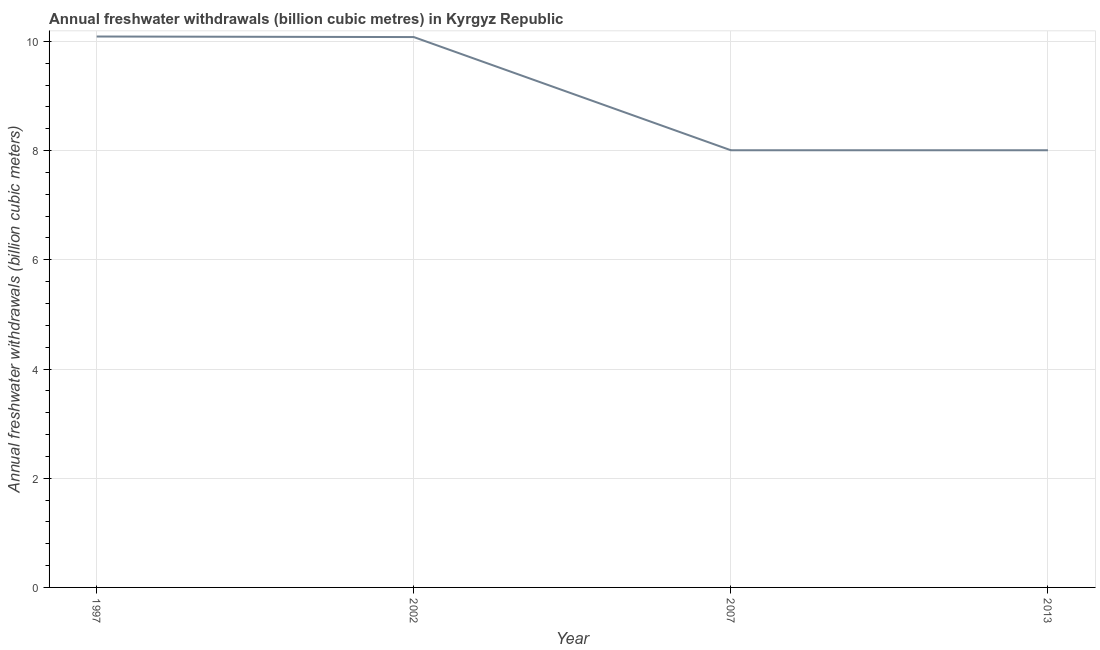What is the annual freshwater withdrawals in 2007?
Provide a short and direct response. 8.01. Across all years, what is the maximum annual freshwater withdrawals?
Ensure brevity in your answer.  10.09. Across all years, what is the minimum annual freshwater withdrawals?
Keep it short and to the point. 8.01. What is the sum of the annual freshwater withdrawals?
Ensure brevity in your answer.  36.18. What is the difference between the annual freshwater withdrawals in 2002 and 2013?
Ensure brevity in your answer.  2.07. What is the average annual freshwater withdrawals per year?
Your answer should be very brief. 9.05. What is the median annual freshwater withdrawals?
Your answer should be very brief. 9.04. In how many years, is the annual freshwater withdrawals greater than 5.2 billion cubic meters?
Give a very brief answer. 4. What is the ratio of the annual freshwater withdrawals in 1997 to that in 2013?
Your answer should be very brief. 1.26. Is the annual freshwater withdrawals in 2007 less than that in 2013?
Your answer should be very brief. No. Is the difference between the annual freshwater withdrawals in 1997 and 2013 greater than the difference between any two years?
Give a very brief answer. Yes. What is the difference between the highest and the second highest annual freshwater withdrawals?
Provide a short and direct response. 0.01. What is the difference between the highest and the lowest annual freshwater withdrawals?
Your answer should be compact. 2.08. Does the annual freshwater withdrawals monotonically increase over the years?
Your answer should be compact. No. Are the values on the major ticks of Y-axis written in scientific E-notation?
Keep it short and to the point. No. What is the title of the graph?
Provide a short and direct response. Annual freshwater withdrawals (billion cubic metres) in Kyrgyz Republic. What is the label or title of the X-axis?
Give a very brief answer. Year. What is the label or title of the Y-axis?
Keep it short and to the point. Annual freshwater withdrawals (billion cubic meters). What is the Annual freshwater withdrawals (billion cubic meters) in 1997?
Ensure brevity in your answer.  10.09. What is the Annual freshwater withdrawals (billion cubic meters) in 2002?
Your answer should be very brief. 10.08. What is the Annual freshwater withdrawals (billion cubic meters) of 2007?
Offer a very short reply. 8.01. What is the Annual freshwater withdrawals (billion cubic meters) in 2013?
Make the answer very short. 8.01. What is the difference between the Annual freshwater withdrawals (billion cubic meters) in 1997 and 2007?
Give a very brief answer. 2.08. What is the difference between the Annual freshwater withdrawals (billion cubic meters) in 1997 and 2013?
Provide a short and direct response. 2.08. What is the difference between the Annual freshwater withdrawals (billion cubic meters) in 2002 and 2007?
Your answer should be very brief. 2.07. What is the difference between the Annual freshwater withdrawals (billion cubic meters) in 2002 and 2013?
Provide a succinct answer. 2.07. What is the ratio of the Annual freshwater withdrawals (billion cubic meters) in 1997 to that in 2002?
Keep it short and to the point. 1. What is the ratio of the Annual freshwater withdrawals (billion cubic meters) in 1997 to that in 2007?
Offer a very short reply. 1.26. What is the ratio of the Annual freshwater withdrawals (billion cubic meters) in 1997 to that in 2013?
Make the answer very short. 1.26. What is the ratio of the Annual freshwater withdrawals (billion cubic meters) in 2002 to that in 2007?
Offer a very short reply. 1.26. What is the ratio of the Annual freshwater withdrawals (billion cubic meters) in 2002 to that in 2013?
Your answer should be compact. 1.26. What is the ratio of the Annual freshwater withdrawals (billion cubic meters) in 2007 to that in 2013?
Your answer should be very brief. 1. 